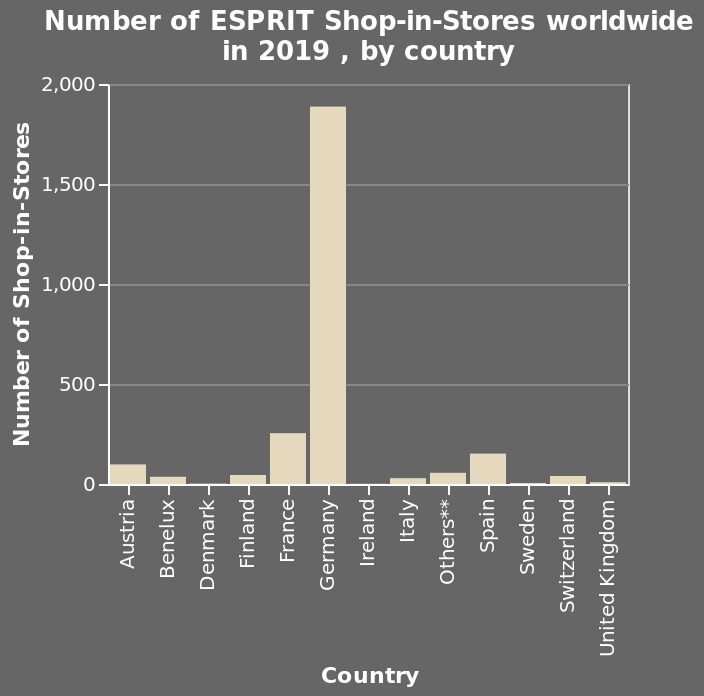<image>
What was the level of the UK and Ireland? For the UK and Ireland, there was low performance. Which country had the highest number of ESPRIT Shop-in-Stores in 2019?  The specific country with the highest number of ESPRIT Shop-in-Stores in 2019 is not mentioned in the given information. How did the Sandemanian countries fare in comparison?  The Sandemanian countries all fared very low. What does the x-axis of the bar graph represent? The x-axis of the bar graph represents the countries, with Austria on one end and the United Kingdom on the other. 